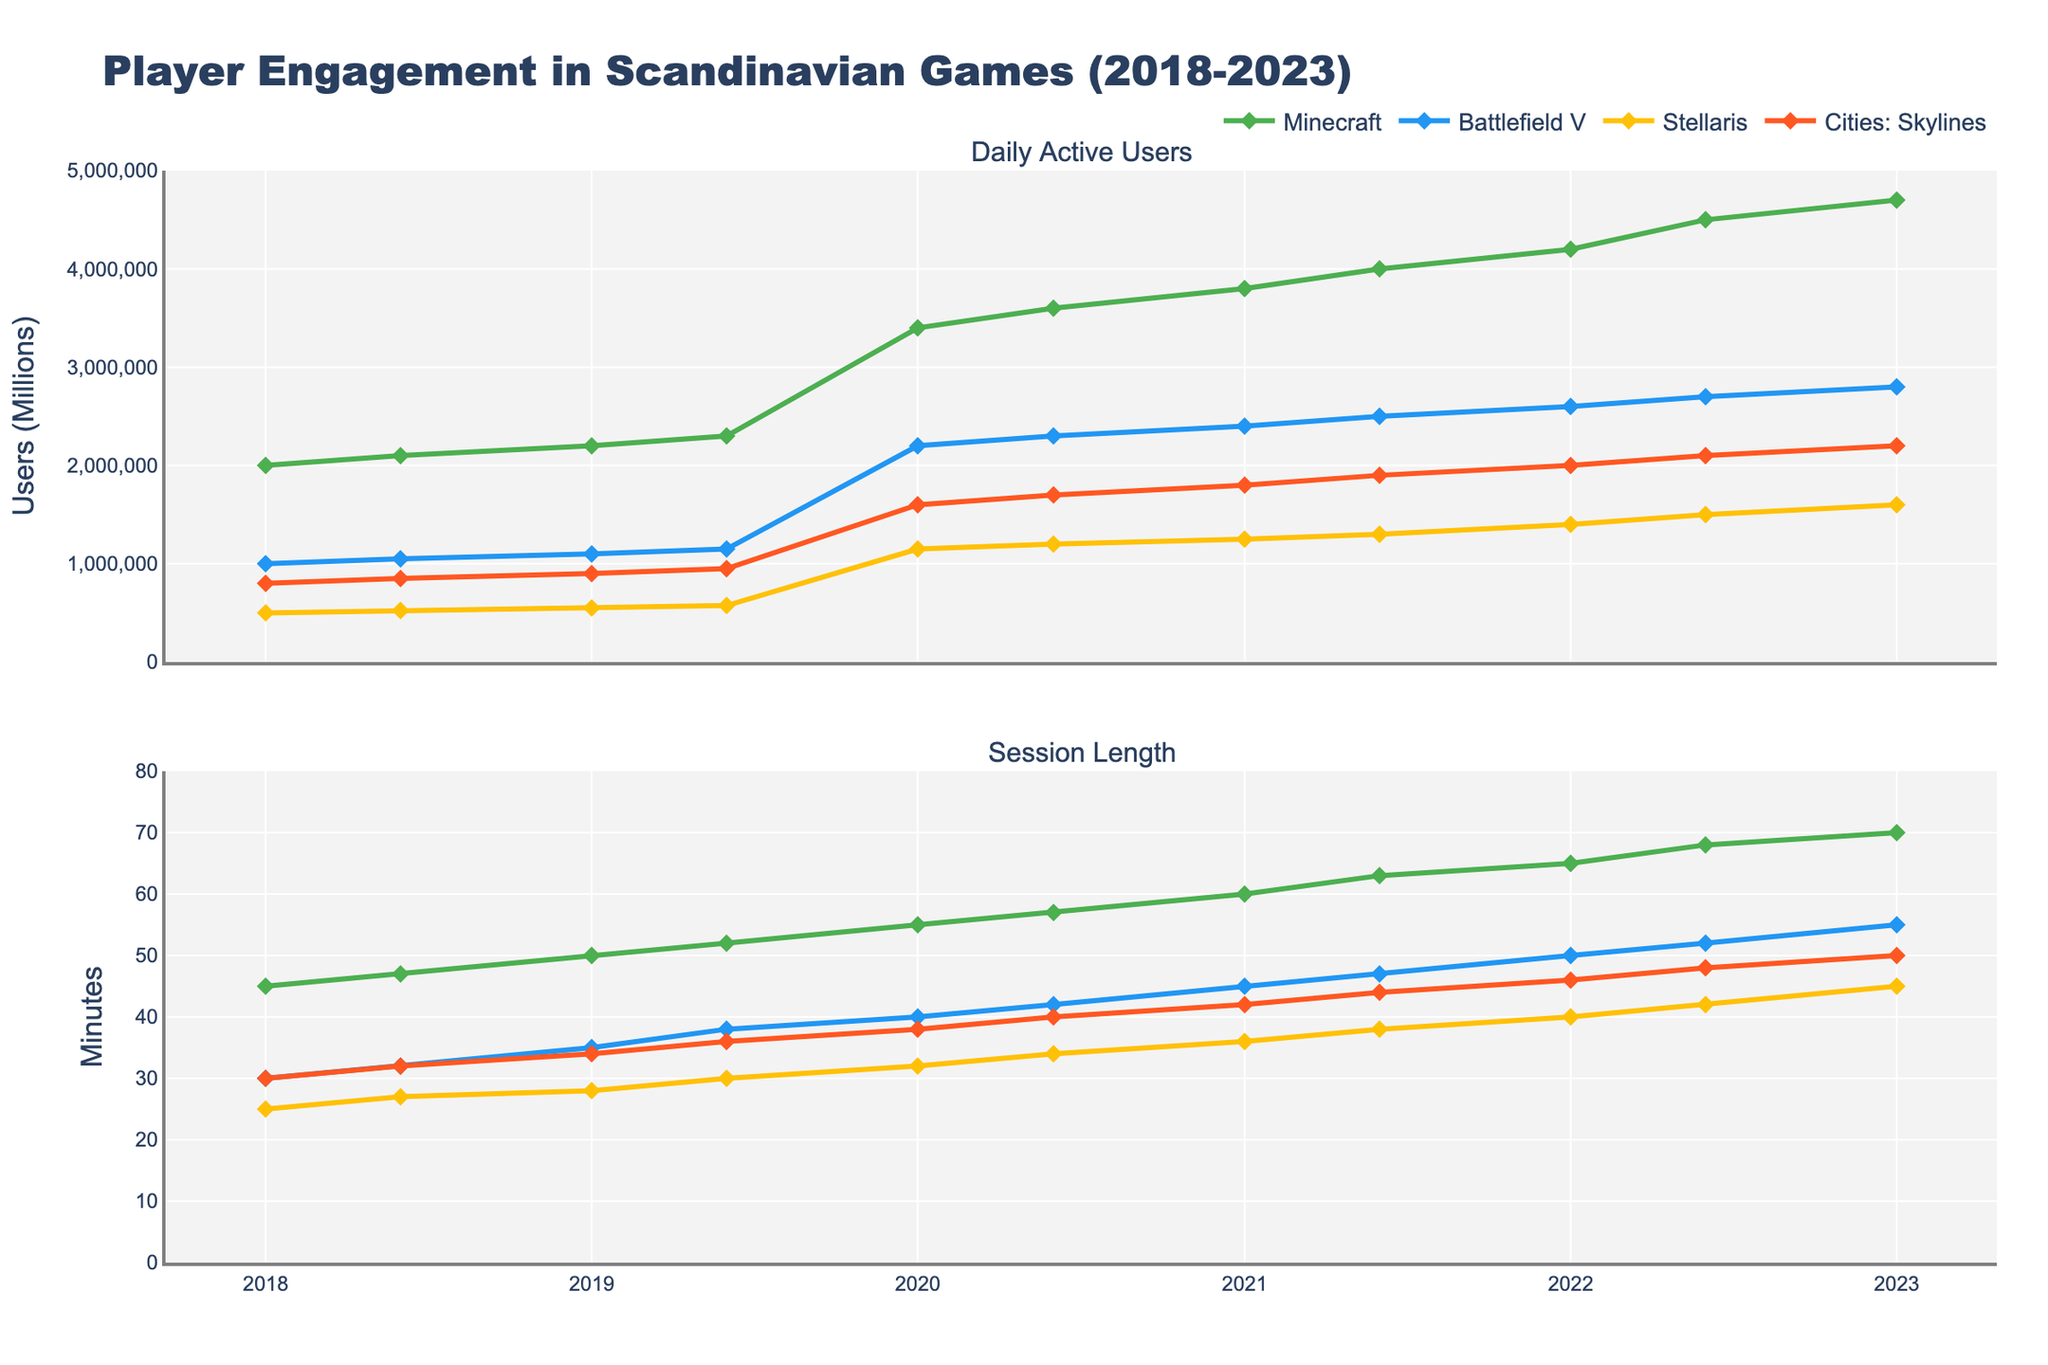Which game saw the most significant increase in Daily Active Users from 2018 to 2023? To determine which game saw the most significant increase, look at the 2018 data point and the 2023 data point for each game and calculate the difference. Minecraft increased from 2,000,000 to 4,700,000; Battlefield V from 1,000,000 to 2,800,000; Stellaris from 500,000 to 1,600,000; and Cities: Skylines from 800,000 to 2,200,000. Therefore, Minecraft saw the largest increase, with 2,700,000 additional users.
Answer: Minecraft Which game had the longest session length in 2023? To find the game with the longest session length in 2023, check the session length data for 2023 for each game. Minecraft had 70 minutes, Battlefield V had 55 minutes, Stellaris had 45 minutes, and Cities: Skylines had 50 minutes. Therefore, Minecraft had the longest session length in 2023.
Answer: Minecraft What was the trend in daily active users for Stellaris from 2020 to 2023? Observe the data points for Stellaris from 2020 to 2023. It went from 1,150,000 in early 2020 to 1,200,000 by mid-2020, then steadily increased to 1,600,000 by early 2023. The trend shows a consistent increase.
Answer: Consistently increasing How did the session length of Battlefield V change from the start of the COVID-19 pandemic (early 2020) to 2023? Look at the session length for Battlefield V from early 2020 (40 minutes) to 2023 (55 minutes). There was a notable increase of 15 minutes in session length over this period.
Answer: Increased by 15 minutes Which game had the least fluctuation in daily active users over the five years? To determine which game had the least fluctuation, compare the range of values (maximum - minimum) for daily active users for each game. Minecraft went from 2,000,000 to 4,700,000 (2,700,000 difference), Battlefield V from 1,000,000 to 2,800,000 (1,800,000 difference), Stellaris from 500,000 to 1,600,000 (1,100,000 difference), and Cities: Skylines from 800,000 to 2,200,000 (1,400,000 difference). Stellaris had the least fluctuation.
Answer: Stellaris By what percentage did Minecraft's session length increase from 2018 to 2023? Calculate the percentage increase using the formula [(final - initial) / initial * 100]. Minecraft's session length increased from 45 to 70 minutes: [(70 - 45) / 45 * 100] = 55.56%.
Answer: 55.56% Compare the session lengths of all four games in early 2020. Which game had the shortest session length? Examine the session lengths for each game in early 2020: Minecraft (55 minutes), Battlefield V (40 minutes), Stellaris (32 minutes), and Cities: Skylines (38 minutes). Stellaris had the shortest session length.
Answer: Stellaris What is the average session length for Minecraft over the five-year period? Sum the session lengths for Minecraft over the five-year period and divide by the number of periods: (45+47+50+52+55+57+60+63+65+68+70)/11 = 58.27 minutes.
Answer: 58.27 minutes 